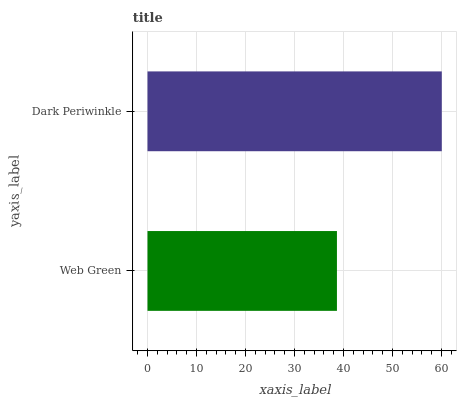Is Web Green the minimum?
Answer yes or no. Yes. Is Dark Periwinkle the maximum?
Answer yes or no. Yes. Is Dark Periwinkle the minimum?
Answer yes or no. No. Is Dark Periwinkle greater than Web Green?
Answer yes or no. Yes. Is Web Green less than Dark Periwinkle?
Answer yes or no. Yes. Is Web Green greater than Dark Periwinkle?
Answer yes or no. No. Is Dark Periwinkle less than Web Green?
Answer yes or no. No. Is Dark Periwinkle the high median?
Answer yes or no. Yes. Is Web Green the low median?
Answer yes or no. Yes. Is Web Green the high median?
Answer yes or no. No. Is Dark Periwinkle the low median?
Answer yes or no. No. 